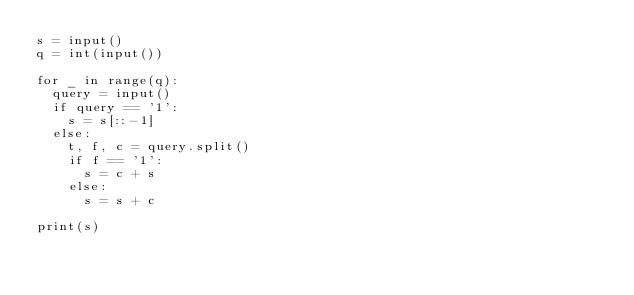<code> <loc_0><loc_0><loc_500><loc_500><_Python_>s = input()
q = int(input())

for _ in range(q):
  query = input()
  if query == '1':
    s = s[::-1]
  else:
    t, f, c = query.split()
    if f == '1':
      s = c + s
    else:
      s = s + c
      
print(s)
</code> 